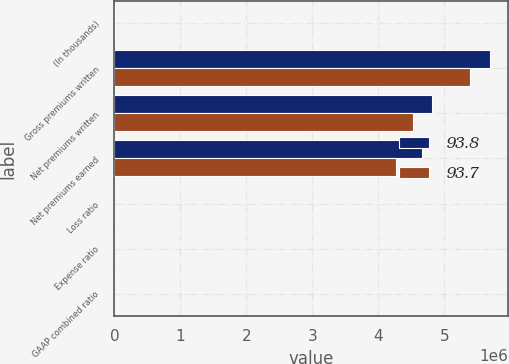Convert chart to OTSL. <chart><loc_0><loc_0><loc_500><loc_500><stacked_bar_chart><ecel><fcel>(In thousands)<fcel>Gross premiums written<fcel>Net premiums written<fcel>Net premiums earned<fcel>Loss ratio<fcel>Expense ratio<fcel>GAAP combined ratio<nl><fcel>93.8<fcel>2015<fcel>5.68419e+06<fcel>4.81283e+06<fcel>4.65936e+06<fcel>61.2<fcel>31.2<fcel>92.4<nl><fcel>93.7<fcel>2014<fcel>5.38368e+06<fcel>4.51759e+06<fcel>4.27193e+06<fcel>60.2<fcel>31.6<fcel>91.8<nl></chart> 